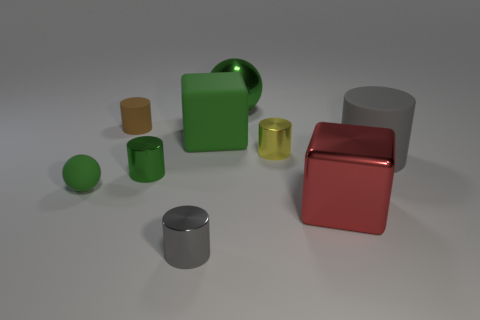Are there fewer yellow cylinders that are left of the tiny gray thing than green rubber things to the left of the big metal ball?
Provide a short and direct response. Yes. What number of large things are cubes or gray cylinders?
Your answer should be compact. 3. Is the shape of the small matte object that is behind the green matte sphere the same as the gray object right of the big matte cube?
Your answer should be very brief. Yes. There is a gray matte thing in front of the metal thing that is behind the cube that is behind the small yellow cylinder; what is its size?
Your answer should be very brief. Large. What is the size of the gray thing that is right of the tiny gray cylinder?
Offer a terse response. Large. There is a sphere that is in front of the small brown object; what is its material?
Provide a short and direct response. Rubber. How many gray things are cylinders or tiny cylinders?
Offer a terse response. 2. Is the tiny yellow cylinder made of the same material as the sphere that is in front of the gray rubber thing?
Your answer should be very brief. No. Is the number of small metal cylinders that are behind the large gray matte thing the same as the number of tiny green shiny objects that are behind the big green block?
Offer a very short reply. No. Do the red block and the cylinder that is behind the yellow object have the same size?
Keep it short and to the point. No. 